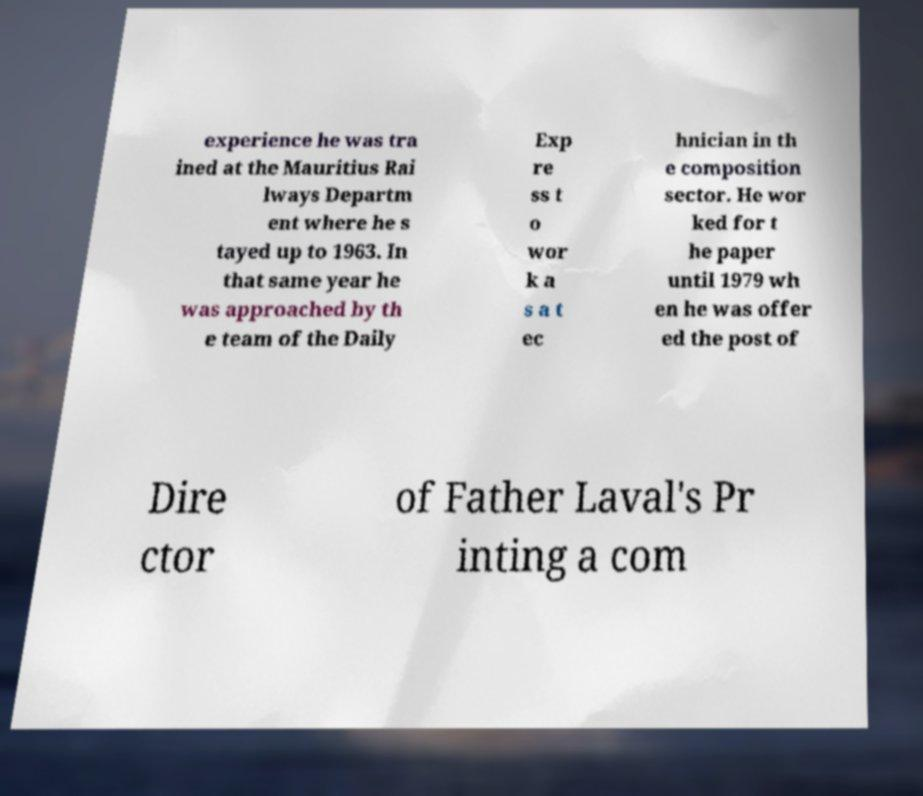Could you extract and type out the text from this image? experience he was tra ined at the Mauritius Rai lways Departm ent where he s tayed up to 1963. In that same year he was approached by th e team of the Daily Exp re ss t o wor k a s a t ec hnician in th e composition sector. He wor ked for t he paper until 1979 wh en he was offer ed the post of Dire ctor of Father Laval's Pr inting a com 